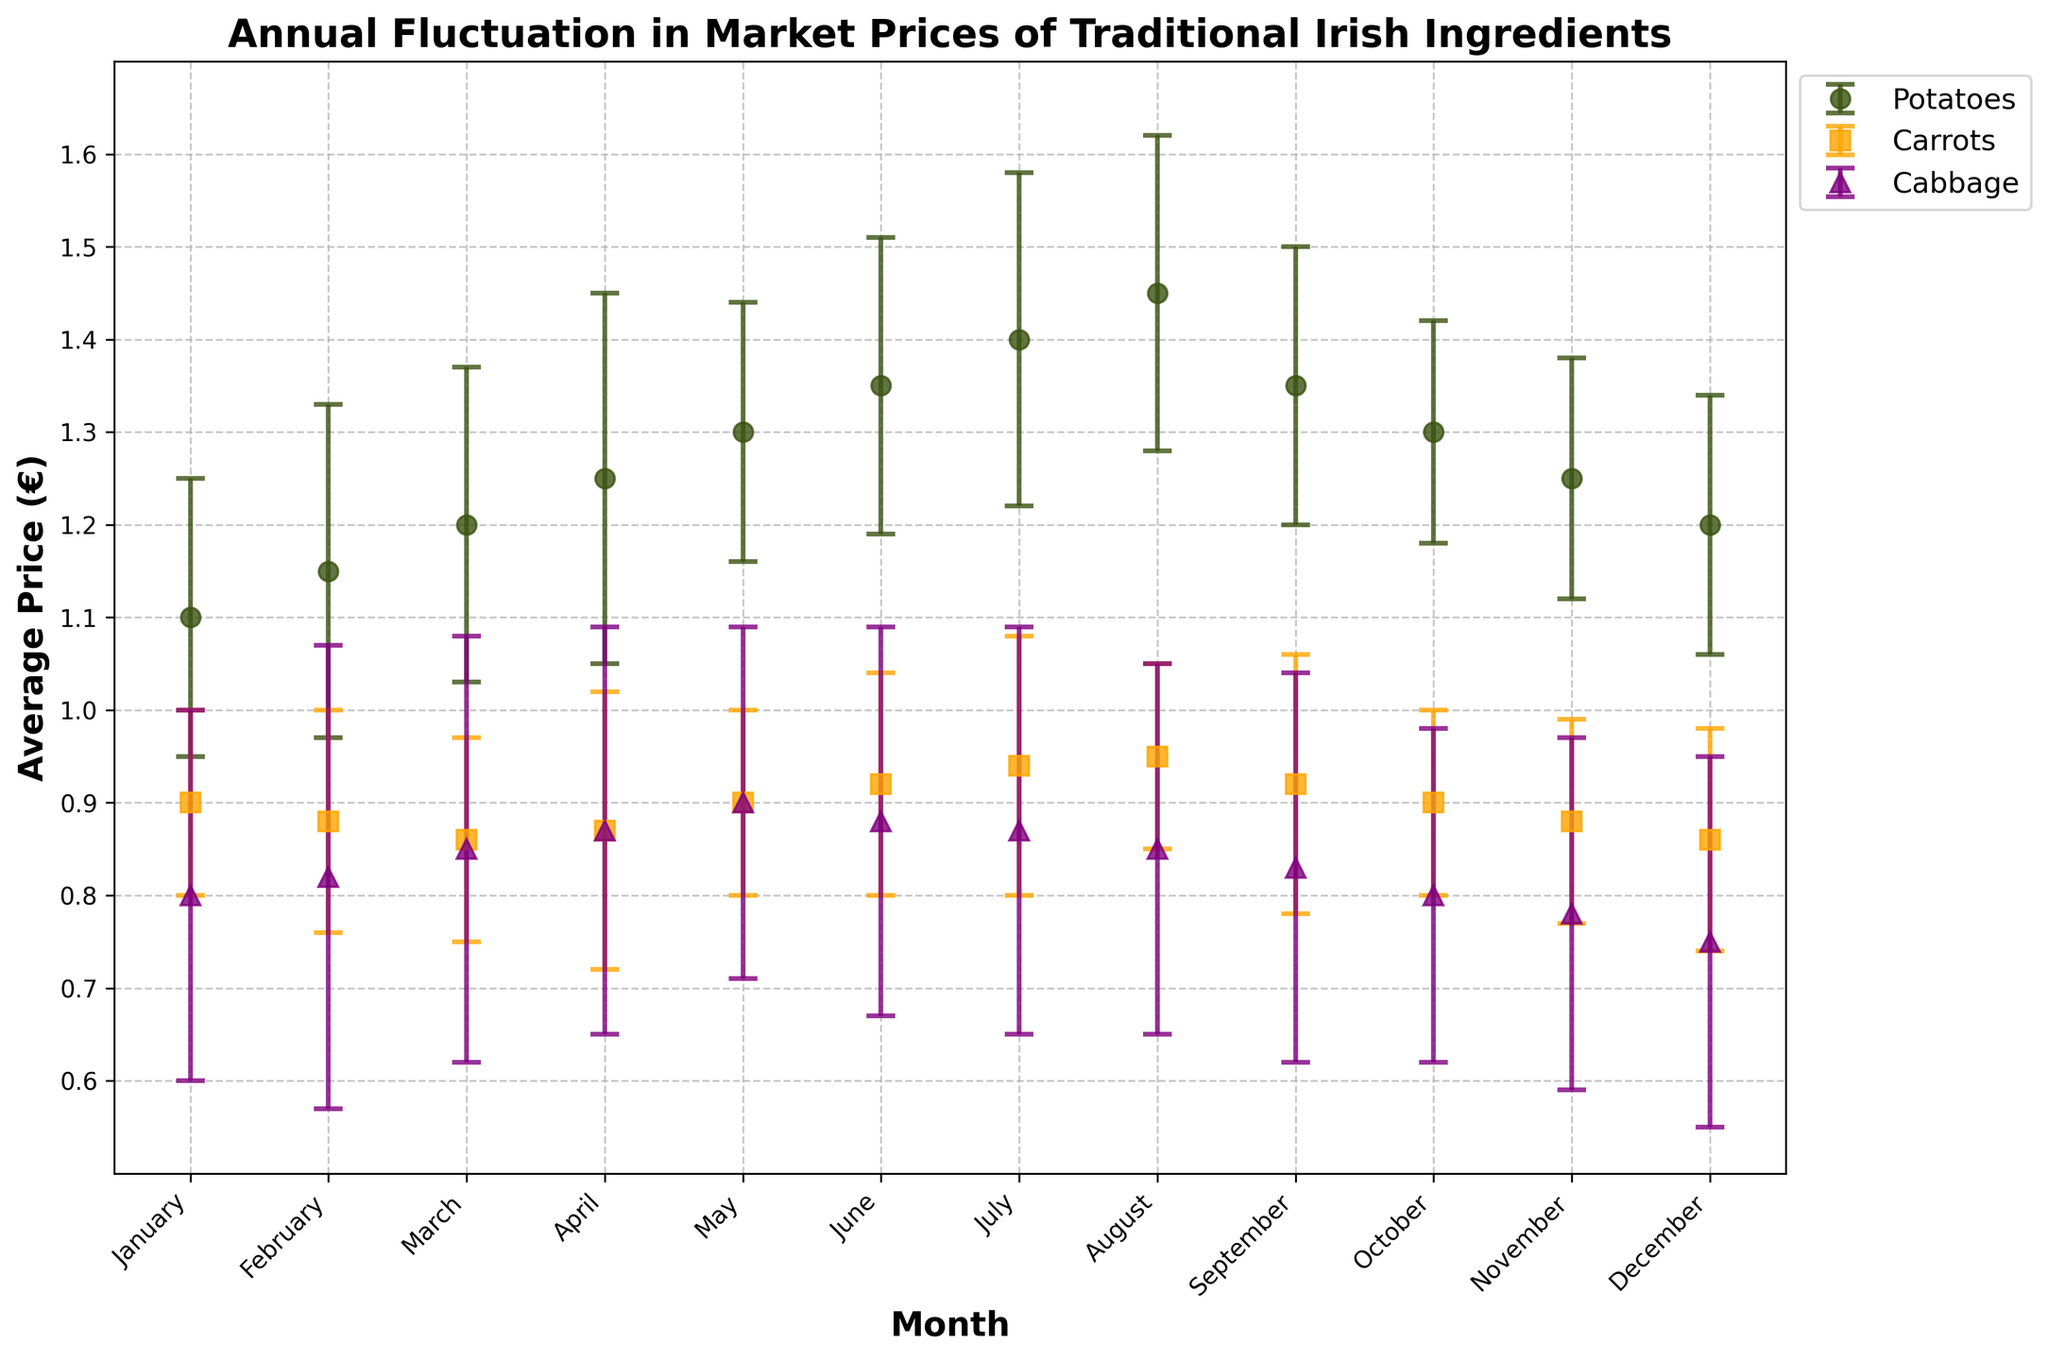What is the title of the plot? The title is located at the top of the plot and usually describes the main focus of the plot.
Answer: Annual Fluctuation in Market Prices of Traditional Irish Ingredients What are the three ingredients shown in the plot? Observe the legend located usually at one side of the plot which labels each line.
Answer: Potatoes, Carrots, Cabbage Which ingredient shows the highest average price in August? Look for the data points in August and check the y-values for each ingredient.
Answer: Potatoes In which month do carrots have the lowest average price? Trace the line for carrots and find the month with the lowest point on the y-axis.
Answer: March What is the average price of cabbage in July? Find the data point for cabbage in July on the y-axis.
Answer: 0.87 By how much does the average price of potatoes increase from January to August? Subtract the average price of potatoes in January from its average price in August.
Answer: 0.35 Which month has the smallest standard deviation for carrots? Check which error bar for carrots is the smallest in length, which indicates the smallest standard deviation.
Answer: August Compare the average prices of carrots and cabbage in December. Look for the data points for both carrots and cabbage in December and compare their y-values.
Answer: Carrots are more expensive than cabbage What is the range of the average price of cabbage throughout the year? Find the maximum and minimum values for cabbage on the y-axis and subtract the minimum from the maximum.
Answer: 0.15 Which ingredient shows the most significant fluctuation in prices, based on the standard deviations? Observe the length of the error bars for each ingredient throughout the months and identify which has the largest fluctuations.
Answer: Cabbage 